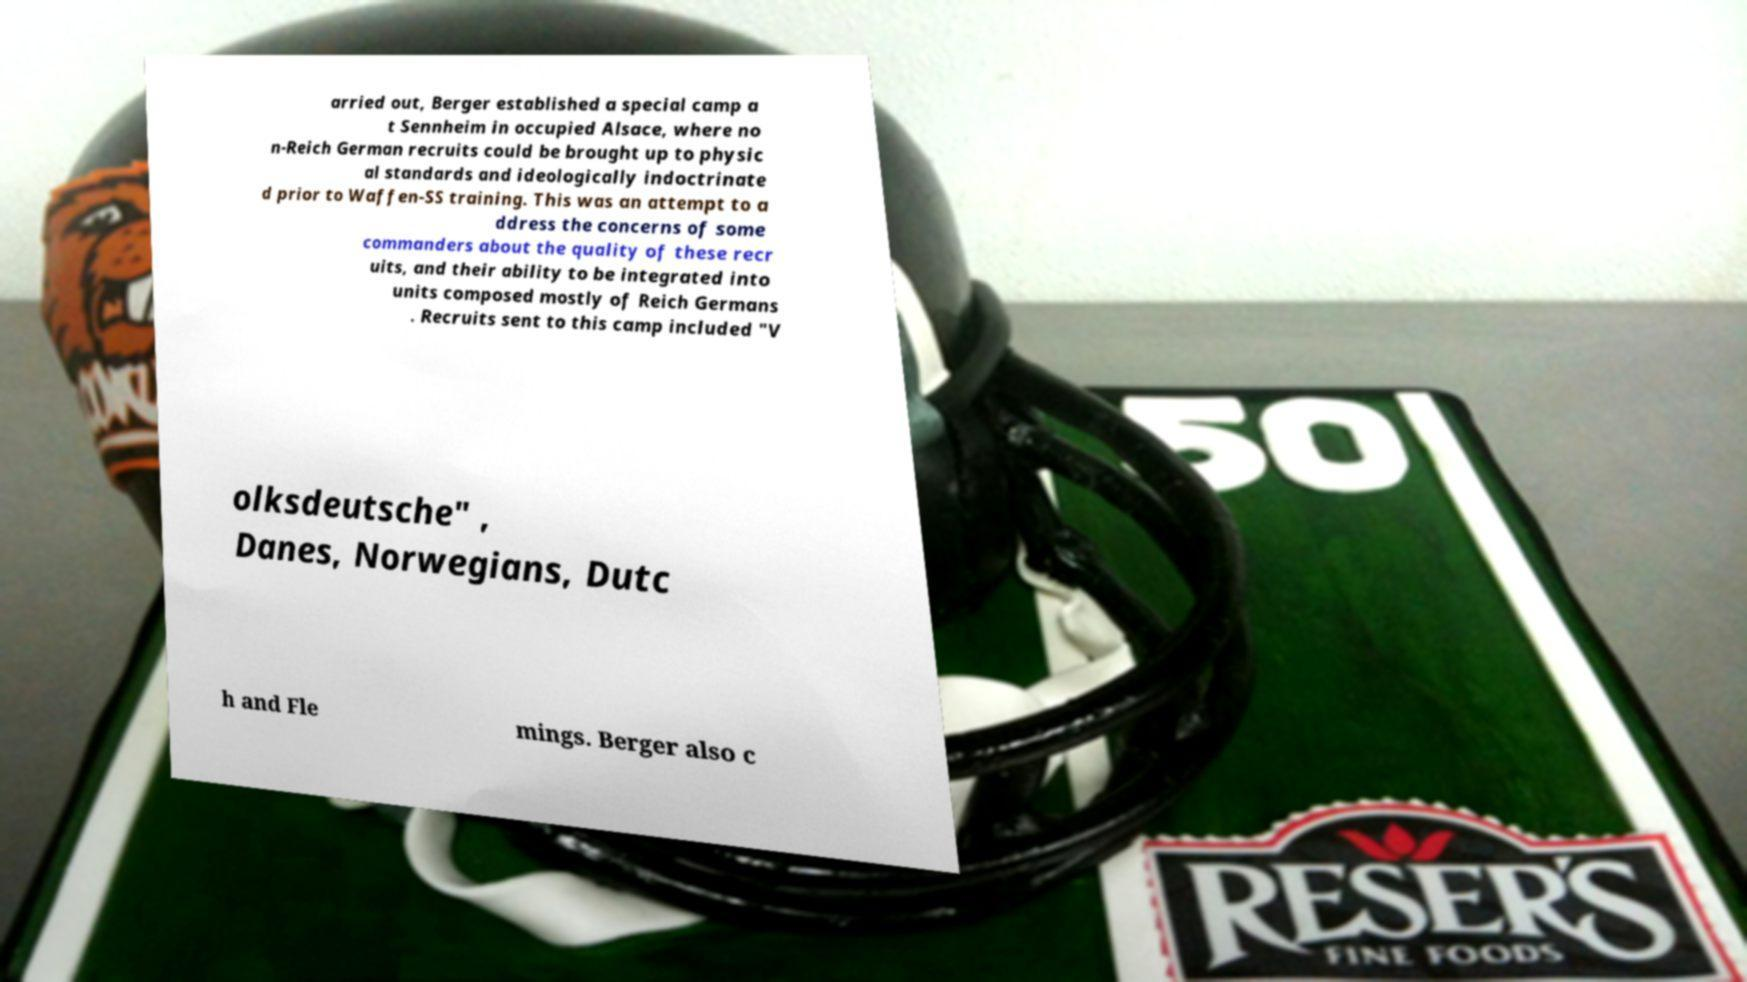Please identify and transcribe the text found in this image. arried out, Berger established a special camp a t Sennheim in occupied Alsace, where no n-Reich German recruits could be brought up to physic al standards and ideologically indoctrinate d prior to Waffen-SS training. This was an attempt to a ddress the concerns of some commanders about the quality of these recr uits, and their ability to be integrated into units composed mostly of Reich Germans . Recruits sent to this camp included "V olksdeutsche" , Danes, Norwegians, Dutc h and Fle mings. Berger also c 